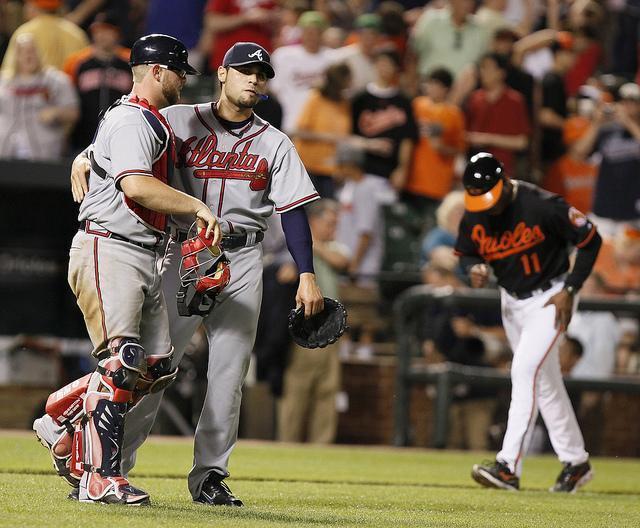How many people are in the picture?
Give a very brief answer. 14. How many birds are in the picture?
Give a very brief answer. 0. 